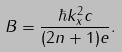<formula> <loc_0><loc_0><loc_500><loc_500>B = \frac { \hbar { k } _ { x } ^ { 2 } c } { ( 2 n + 1 ) e } .</formula> 